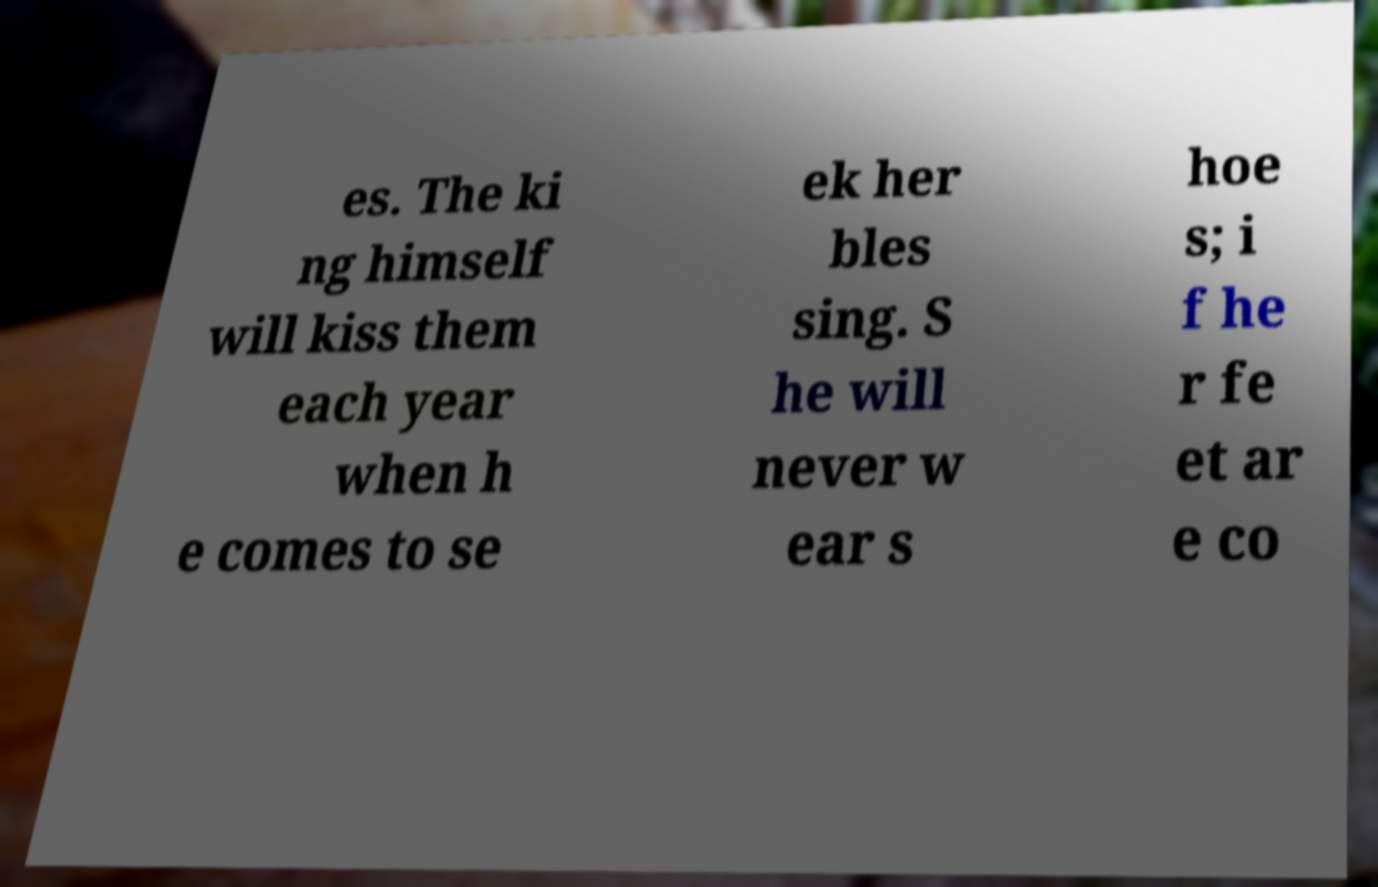Could you assist in decoding the text presented in this image and type it out clearly? es. The ki ng himself will kiss them each year when h e comes to se ek her bles sing. S he will never w ear s hoe s; i f he r fe et ar e co 